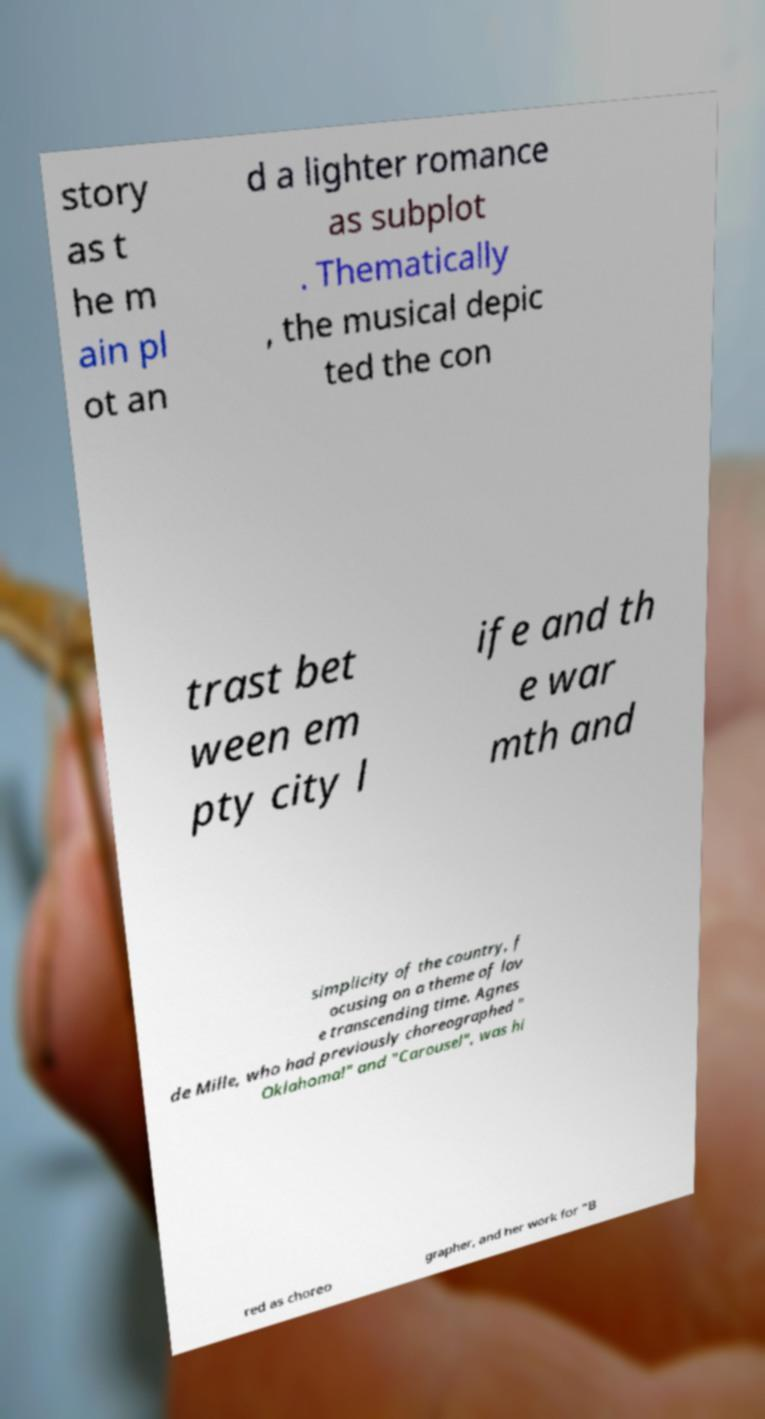Please read and relay the text visible in this image. What does it say? story as t he m ain pl ot an d a lighter romance as subplot . Thematically , the musical depic ted the con trast bet ween em pty city l ife and th e war mth and simplicity of the country, f ocusing on a theme of lov e transcending time. Agnes de Mille, who had previously choreographed " Oklahoma!" and "Carousel", was hi red as choreo grapher, and her work for "B 